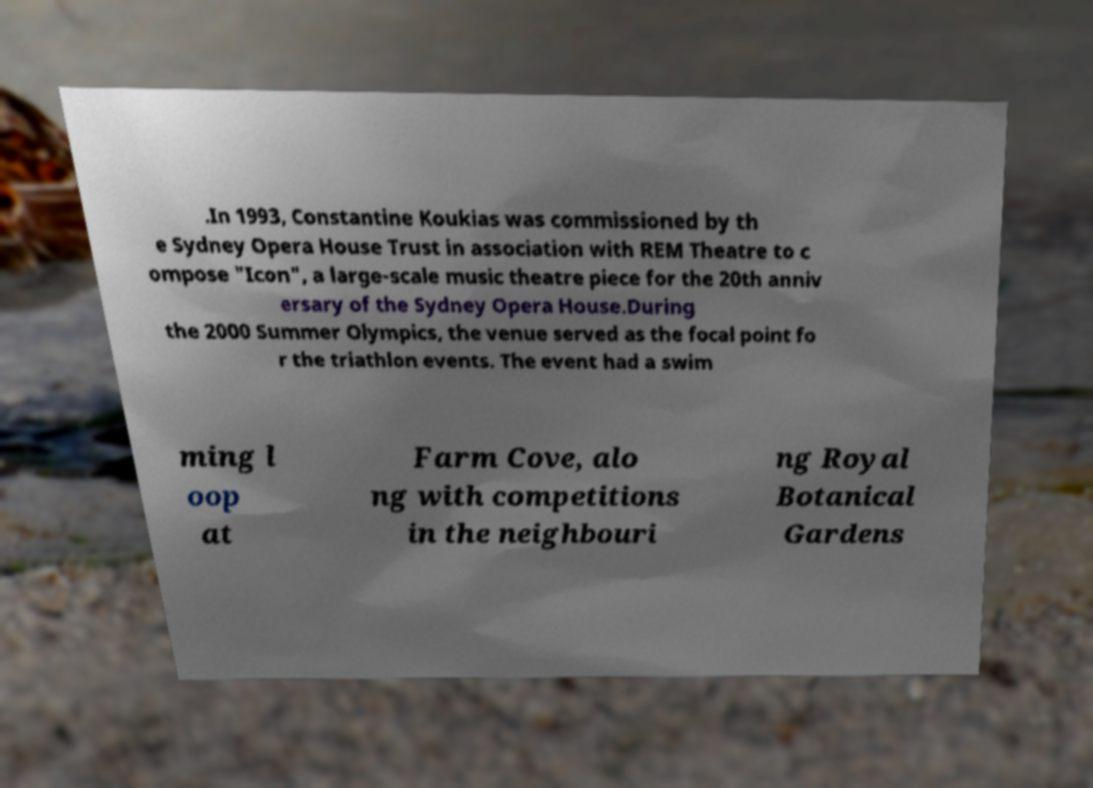I need the written content from this picture converted into text. Can you do that? .In 1993, Constantine Koukias was commissioned by th e Sydney Opera House Trust in association with REM Theatre to c ompose "Icon", a large-scale music theatre piece for the 20th anniv ersary of the Sydney Opera House.During the 2000 Summer Olympics, the venue served as the focal point fo r the triathlon events. The event had a swim ming l oop at Farm Cove, alo ng with competitions in the neighbouri ng Royal Botanical Gardens 